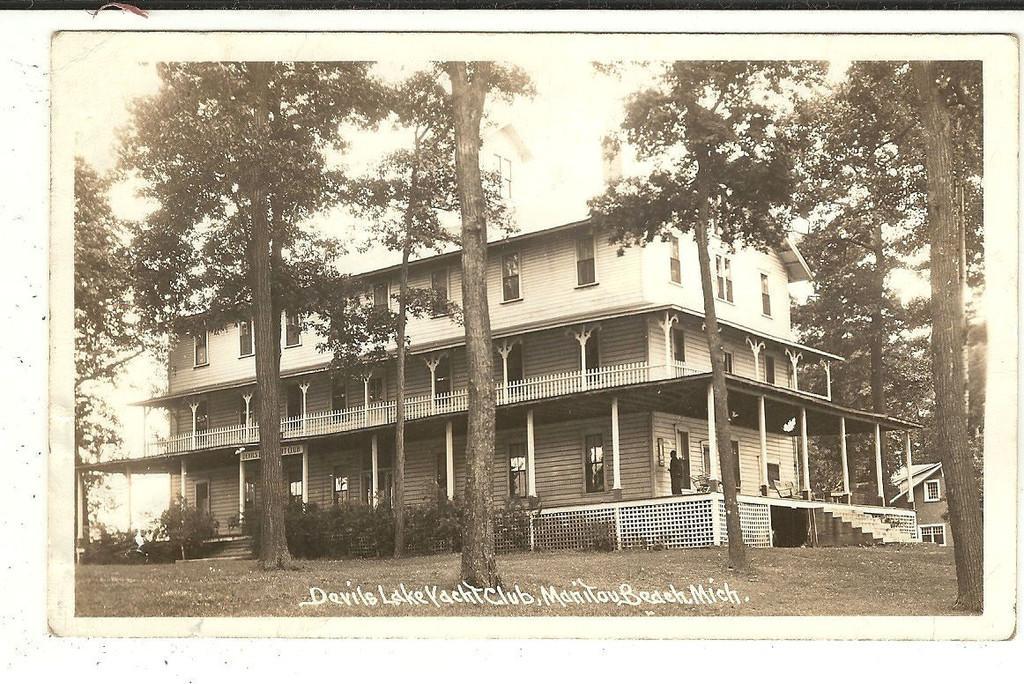Describe this image in one or two sentences. In this image we can see few trees, plants, buildings, stairs and pillars to the building, a person standing near the building, a fence and the sky in the background. 